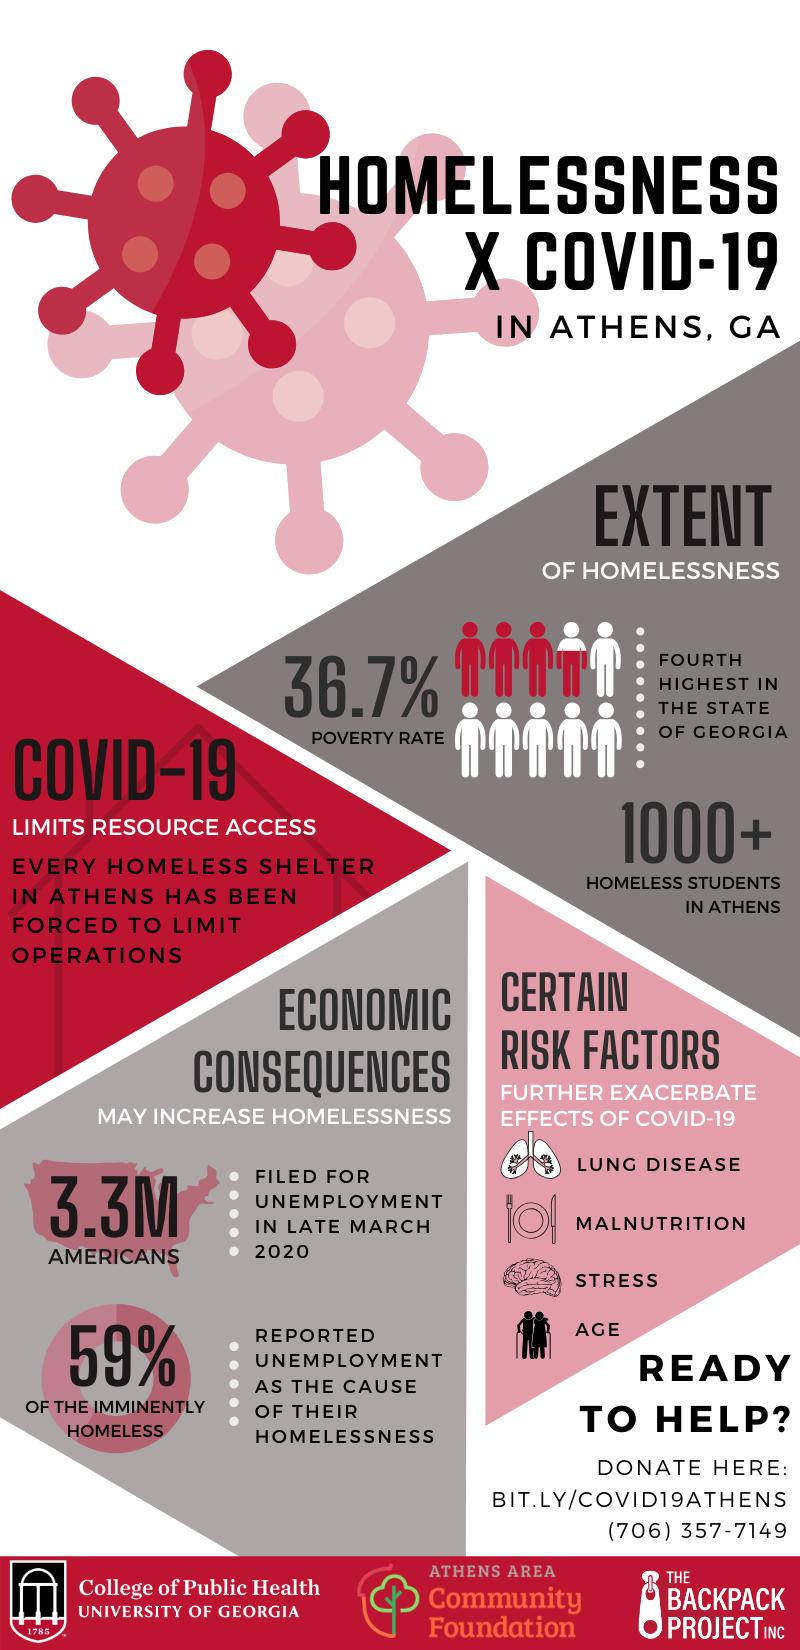Specify some key components in this picture. In a survey of Americans experiencing homelessness, 59% reported unemployment as the cause of their homelessness. The effects of COVID-19 are further increased by certain risk factors, including lung disease and malnutrition. In late March 2020, approximately 3.3 million Americans were unemployed. 